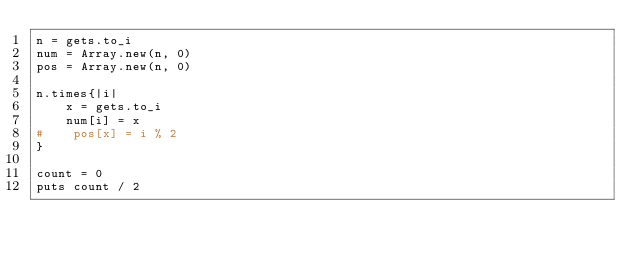Convert code to text. <code><loc_0><loc_0><loc_500><loc_500><_Ruby_>n = gets.to_i
num = Array.new(n, 0)
pos = Array.new(n, 0)

n.times{|i|
    x = gets.to_i
    num[i] = x
#    pos[x] = i % 2
}

count = 0
puts count / 2
</code> 